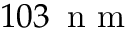Convert formula to latex. <formula><loc_0><loc_0><loc_500><loc_500>1 0 3 \, n m</formula> 